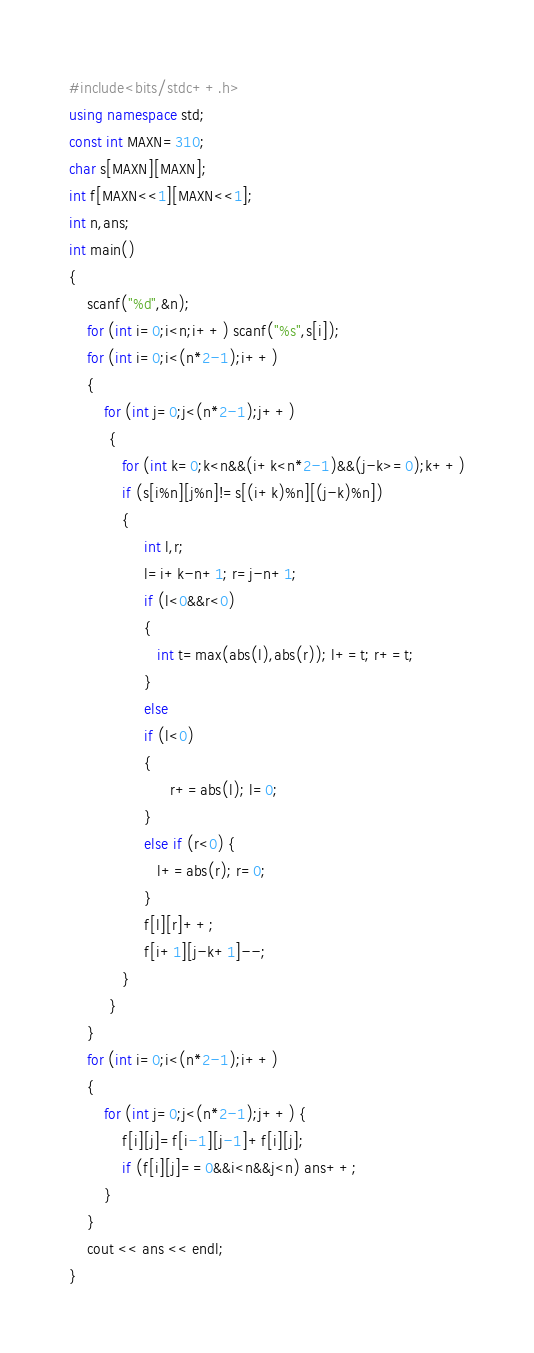<code> <loc_0><loc_0><loc_500><loc_500><_C++_>#include<bits/stdc++.h>
using namespace std;
const int MAXN=310;
char s[MAXN][MAXN];
int f[MAXN<<1][MAXN<<1];
int n,ans;
int main()
{
	scanf("%d",&n);
	for (int i=0;i<n;i++) scanf("%s",s[i]);
	for (int i=0;i<(n*2-1);i++)
	{
		for (int j=0;j<(n*2-1);j++)
		 {
		 	for (int k=0;k<n&&(i+k<n*2-1)&&(j-k>=0);k++)
		 	if (s[i%n][j%n]!=s[(i+k)%n][(j-k)%n])
		 	{
                 int l,r;
                 l=i+k-n+1; r=j-n+1;
                 if (l<0&&r<0)
                 {
                 	int t=max(abs(l),abs(r)); l+=t; r+=t;
                 }
                 else 
                 if (l<0)
                 {
                       r+=abs(l); l=0;
                 }
                 else if (r<0) {
                 	l+=abs(r); r=0;
                 }
                 f[l][r]++;
                 f[i+1][j-k+1]--;
		 	}
		 }
	}
	for (int i=0;i<(n*2-1);i++)
	{
		for (int j=0;j<(n*2-1);j++) {
			f[i][j]=f[i-1][j-1]+f[i][j];
			if (f[i][j]==0&&i<n&&j<n) ans++; 
		}
	}
	cout << ans << endl;
}</code> 